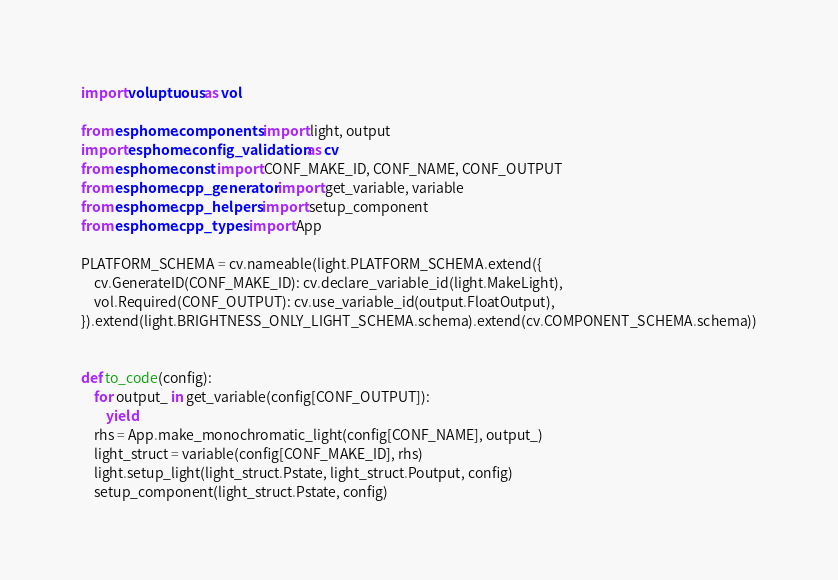Convert code to text. <code><loc_0><loc_0><loc_500><loc_500><_Python_>import voluptuous as vol

from esphome.components import light, output
import esphome.config_validation as cv
from esphome.const import CONF_MAKE_ID, CONF_NAME, CONF_OUTPUT
from esphome.cpp_generator import get_variable, variable
from esphome.cpp_helpers import setup_component
from esphome.cpp_types import App

PLATFORM_SCHEMA = cv.nameable(light.PLATFORM_SCHEMA.extend({
    cv.GenerateID(CONF_MAKE_ID): cv.declare_variable_id(light.MakeLight),
    vol.Required(CONF_OUTPUT): cv.use_variable_id(output.FloatOutput),
}).extend(light.BRIGHTNESS_ONLY_LIGHT_SCHEMA.schema).extend(cv.COMPONENT_SCHEMA.schema))


def to_code(config):
    for output_ in get_variable(config[CONF_OUTPUT]):
        yield
    rhs = App.make_monochromatic_light(config[CONF_NAME], output_)
    light_struct = variable(config[CONF_MAKE_ID], rhs)
    light.setup_light(light_struct.Pstate, light_struct.Poutput, config)
    setup_component(light_struct.Pstate, config)
</code> 